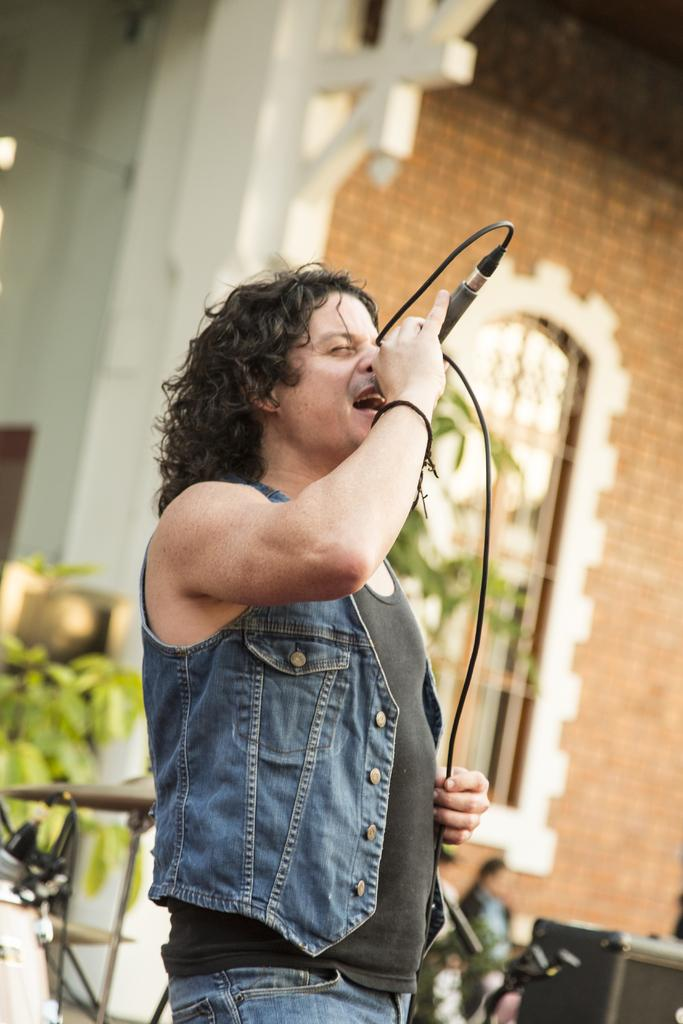What is the person in the image doing? The person is singing. What is the person holding while singing? The person is holding a microphone in his hand. What can be seen in the background of the image? There is a building and trees in the background of the image. What type of disease is affecting the flock of birds in the image? There are no birds or any mention of a disease in the image. 